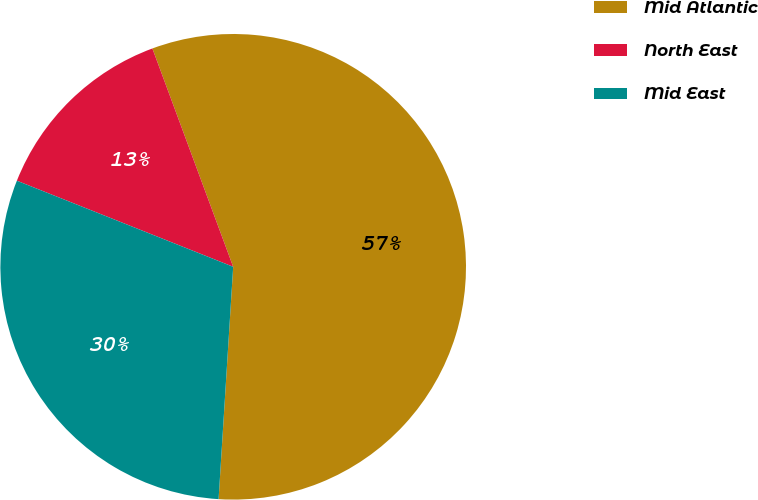<chart> <loc_0><loc_0><loc_500><loc_500><pie_chart><fcel>Mid Atlantic<fcel>North East<fcel>Mid East<nl><fcel>56.64%<fcel>13.33%<fcel>30.03%<nl></chart> 